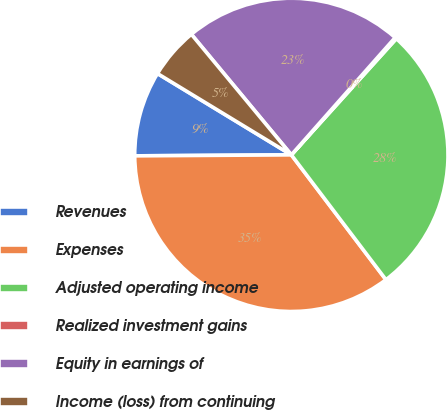Convert chart to OTSL. <chart><loc_0><loc_0><loc_500><loc_500><pie_chart><fcel>Revenues<fcel>Expenses<fcel>Adjusted operating income<fcel>Realized investment gains<fcel>Equity in earnings of<fcel>Income (loss) from continuing<nl><fcel>8.79%<fcel>35.22%<fcel>27.99%<fcel>0.16%<fcel>22.55%<fcel>5.29%<nl></chart> 